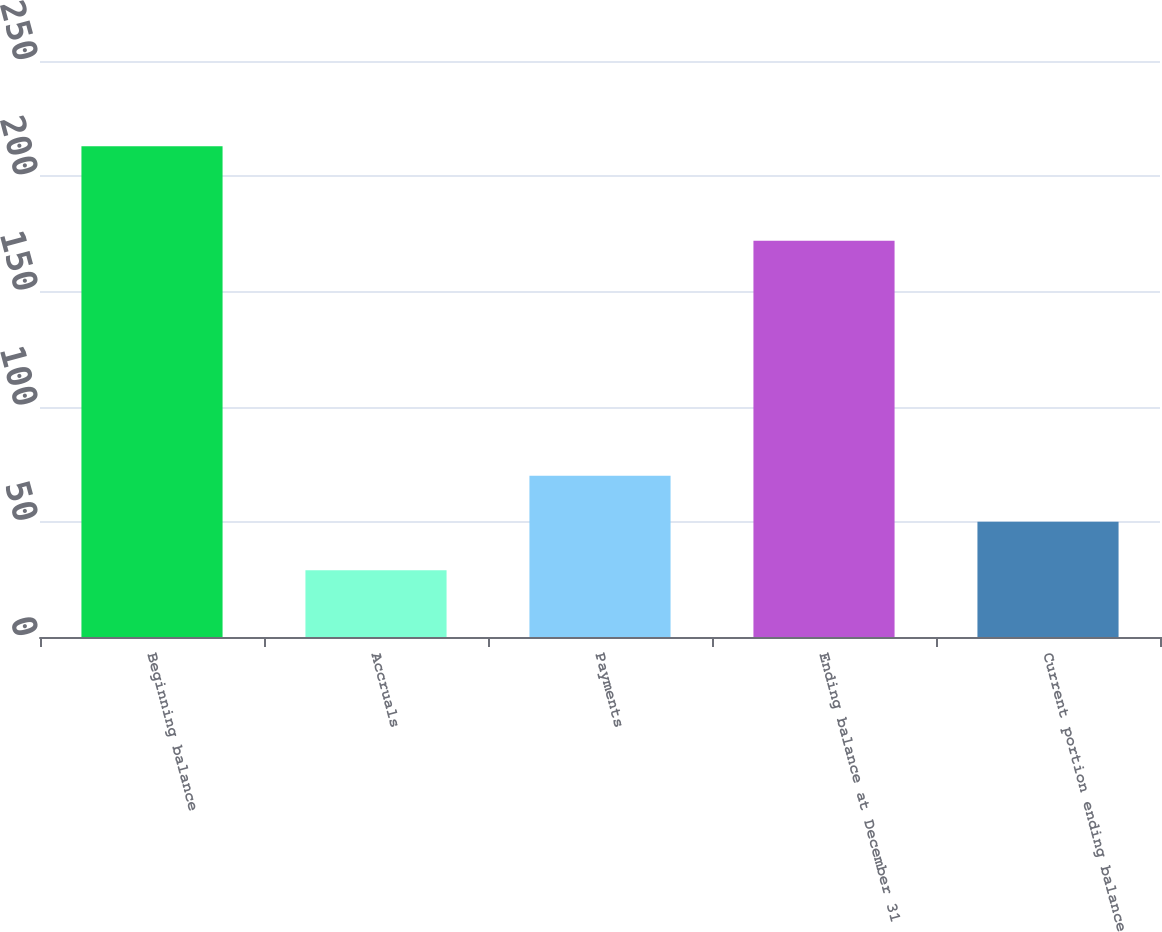Convert chart. <chart><loc_0><loc_0><loc_500><loc_500><bar_chart><fcel>Beginning balance<fcel>Accruals<fcel>Payments<fcel>Ending balance at December 31<fcel>Current portion ending balance<nl><fcel>213<fcel>29<fcel>70<fcel>172<fcel>50<nl></chart> 